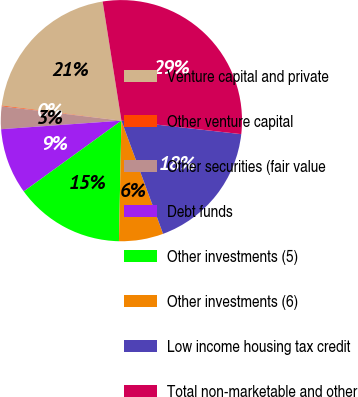<chart> <loc_0><loc_0><loc_500><loc_500><pie_chart><fcel>Venture capital and private<fcel>Other venture capital<fcel>Other securities (fair value<fcel>Debt funds<fcel>Other investments (5)<fcel>Other investments (6)<fcel>Low income housing tax credit<fcel>Total non-marketable and other<nl><fcel>20.52%<fcel>0.1%<fcel>3.02%<fcel>8.85%<fcel>14.69%<fcel>5.94%<fcel>17.6%<fcel>29.27%<nl></chart> 